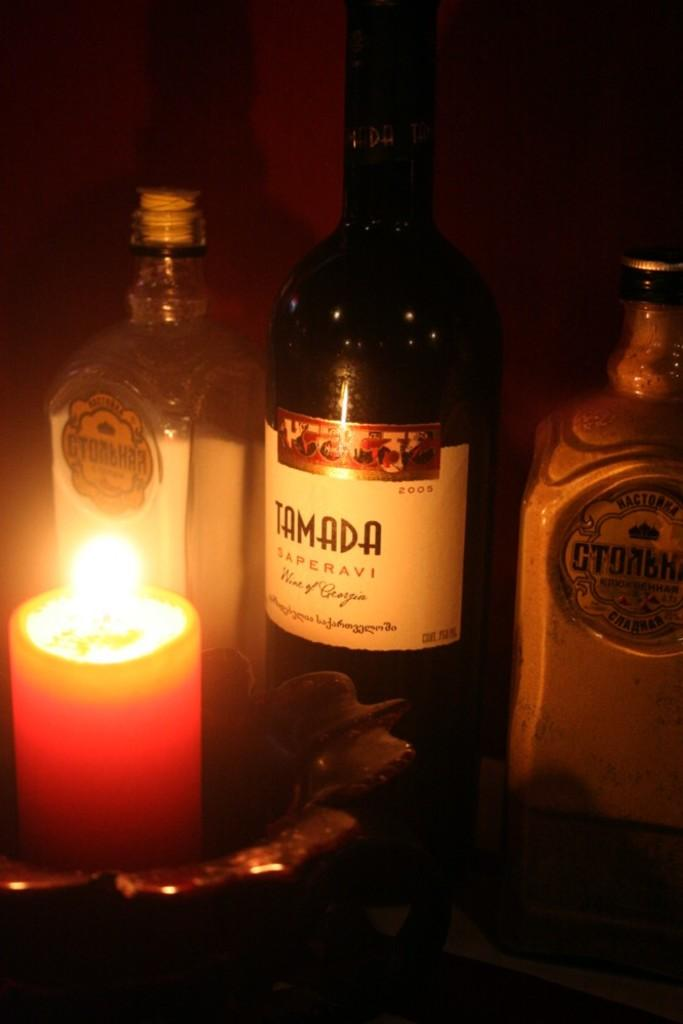<image>
Give a short and clear explanation of the subsequent image. A candle shines light on Tamada a wine of Georgia. 